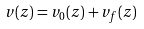<formula> <loc_0><loc_0><loc_500><loc_500>v ( z ) = v _ { 0 } ( z ) + v _ { f } ( z )</formula> 